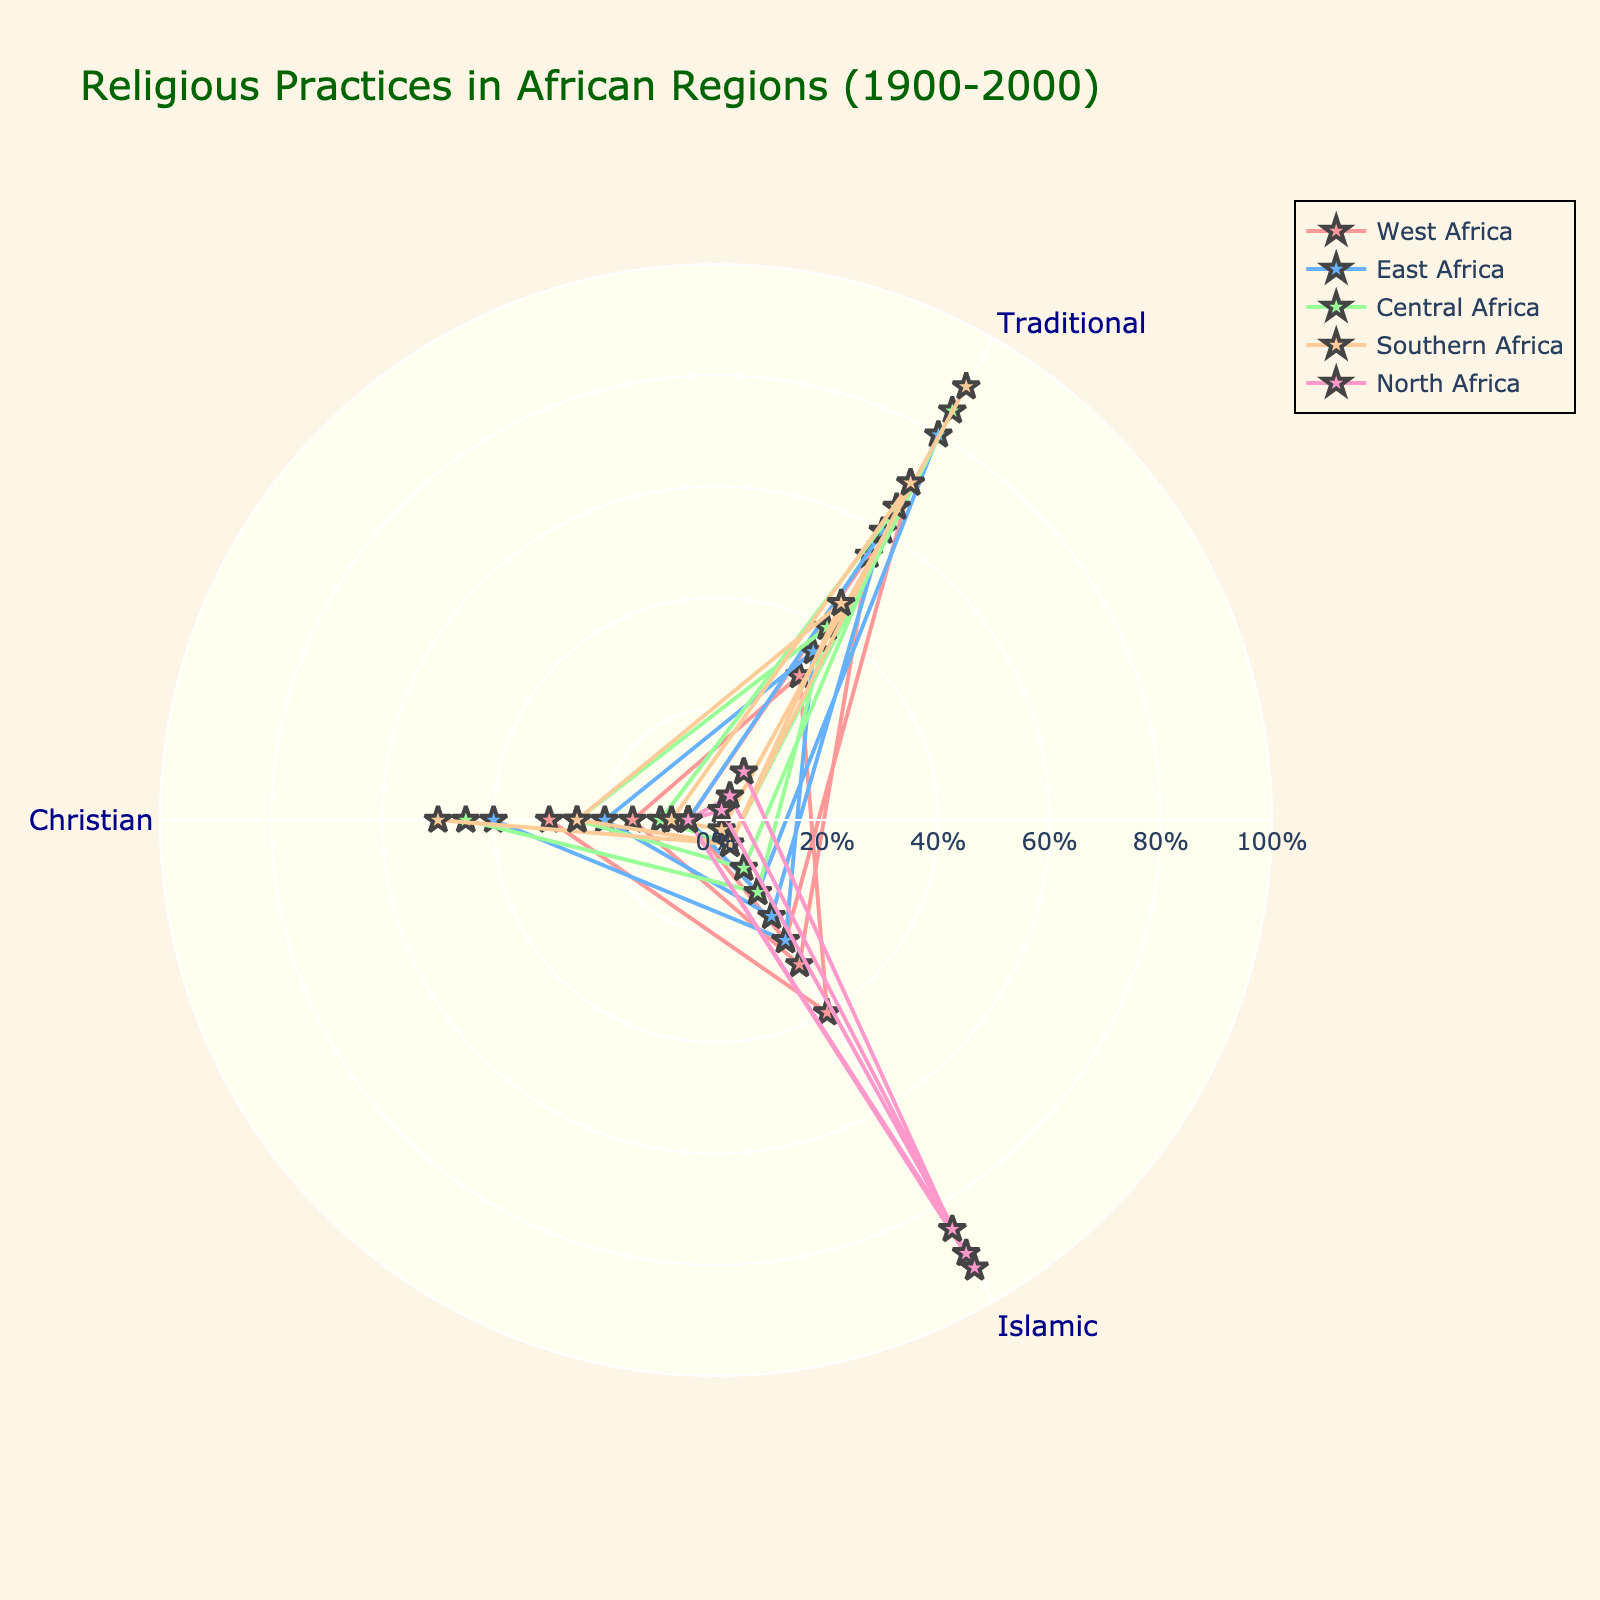What is the title of the figure? The title is generally displayed at the top of the figure. In this case, we expect it to be 'Religious Practices in African Regions (1900-2000)' based on the code description.
Answer: Religious Practices in African Regions (1900-2000) What is the predominant religious practice in West Africa in 1900? Look at the points corresponding to West Africa for the year 1900 in the figure. According to the provided data, the traditional religious practice is the highest proportion.
Answer: Traditional Which region experienced the most significant increase in Christian practices from 1900 to 2000? Find the regions in the plot and compare the Christian proportions in 1900 and 2000. Look for the one with the largest positive change. According to the data, Southern Africa had the largest increase, going from 8% to 50%.
Answer: Southern Africa From 1900 to 2000, did East Africa have a greater increase in Islamic or Christian practices? Compare the proportions of Islamic and Christian practices in East Africa between 1900 and 2000. Islamic practices went from 15% to 25%, an increase of 10%; Christian practices went from 5% to 40%, an increase of 35%.
Answer: Christian Which region has remained predominantly Islamic from 1900 to 2000? Identify regions in the plot where Islamic practices are consistently dominant across the specified timeframe. According to the data, North Africa is predominantly Islamic in 1900, 1950, and 2000.
Answer: North Africa By how much did the proportion of traditional practices decrease in Central Africa from 1900 to 2000? Subtract the proportion of traditional practices in Central Africa in 2000 from that in 1900, based on the data provided. From 85% to 40%, the decrease is 85% - 40% = 45%.
Answer: 45% What is the trend in Islamic practices in Southern Africa from 1900 to 2000? Examine the data points for Southern Africa for Islamic practices over the time period. According to the data, it remains constant at 2% in 1900, 5% in 1950, and 5% in 2000.
Answer: Slight Increase Is there any region where the proportion of Christian practices surpassed traditional practices by 2000? Compare the proportions of Christian and traditional practices for each region in 2000. In the data, Southern Africa and East Africa show higher proportions of Christians compared to traditional practices by 2000.
Answer: Yes, Southern and East Africa What can you say about the dominance of religious practices in North Africa over the century? Check the proportions of traditional, Islamic, and Christian practices in North Africa from 1900 to 2000. You will notice that Islamic practices clearly dominate throughout the century.
Answer: Dominantly Islamic 